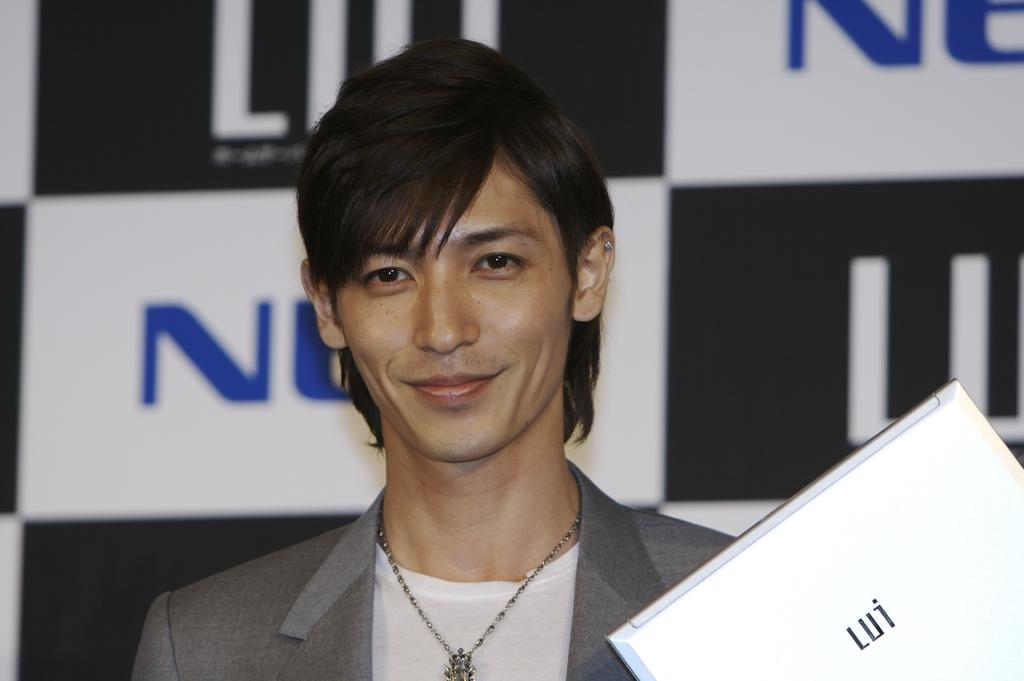What is the main subject in the foreground of the image? There is a person in the foreground of the image. What is the person holding in his hand? The person is holding a laptop in his hand. What can be seen in the background of the image? There is a banner with some text in the background of the image. How many rabbits are visible in the image? There are no rabbits present in the image. What grade is the person in the image? The provided facts do not mention the person's grade, so it cannot be determined from the image. 